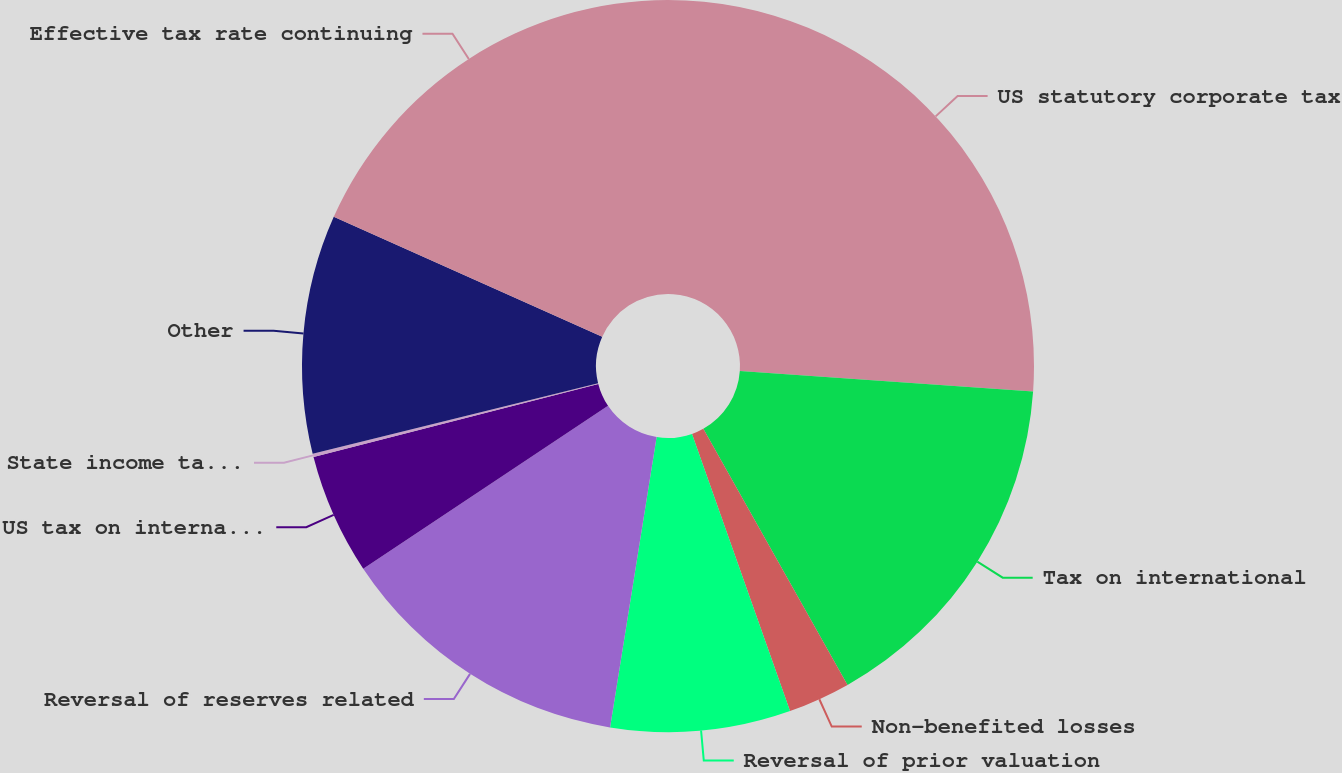Convert chart. <chart><loc_0><loc_0><loc_500><loc_500><pie_chart><fcel>US statutory corporate tax<fcel>Tax on international<fcel>Non-benefited losses<fcel>Reversal of prior valuation<fcel>Reversal of reserves related<fcel>US tax on international<fcel>State income taxes net of<fcel>Other<fcel>Effective tax rate continuing<nl><fcel>26.11%<fcel>15.73%<fcel>2.75%<fcel>7.94%<fcel>13.13%<fcel>5.34%<fcel>0.15%<fcel>10.53%<fcel>18.32%<nl></chart> 